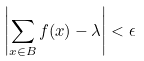<formula> <loc_0><loc_0><loc_500><loc_500>\left | \sum _ { x \in B } f ( x ) - \lambda \right | < \epsilon</formula> 